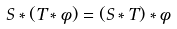<formula> <loc_0><loc_0><loc_500><loc_500>S \ast ( T \ast \phi ) = ( S \ast T ) \ast \phi</formula> 